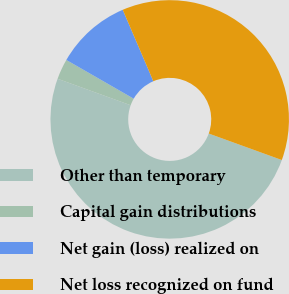<chart> <loc_0><loc_0><loc_500><loc_500><pie_chart><fcel>Other than temporary<fcel>Capital gain distributions<fcel>Net gain (loss) realized on<fcel>Net loss recognized on fund<nl><fcel>50.0%<fcel>2.77%<fcel>10.25%<fcel>36.98%<nl></chart> 